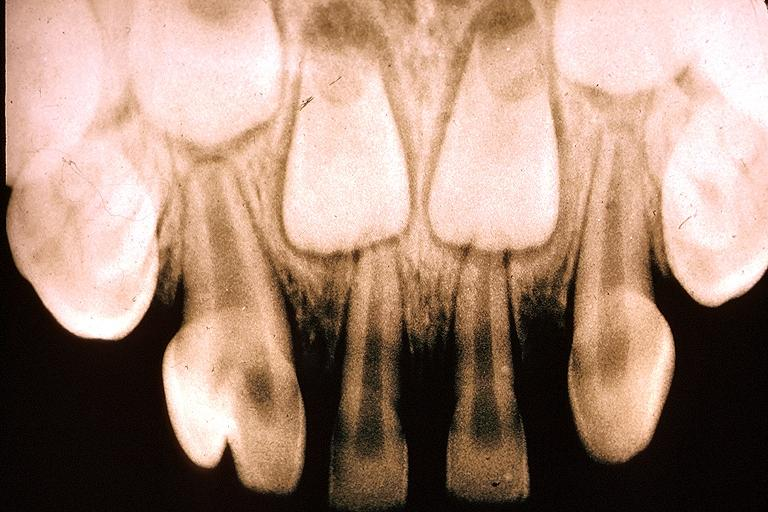does this image show gemination?
Answer the question using a single word or phrase. Yes 